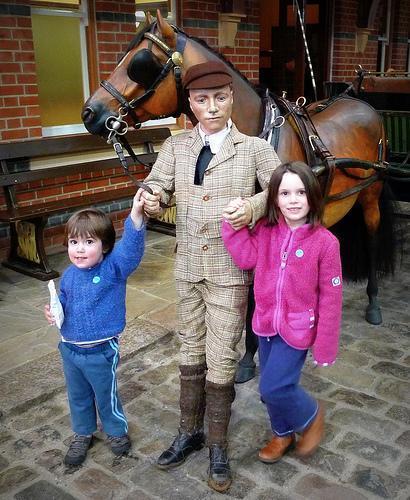How many children are in photo?
Give a very brief answer. 2. 